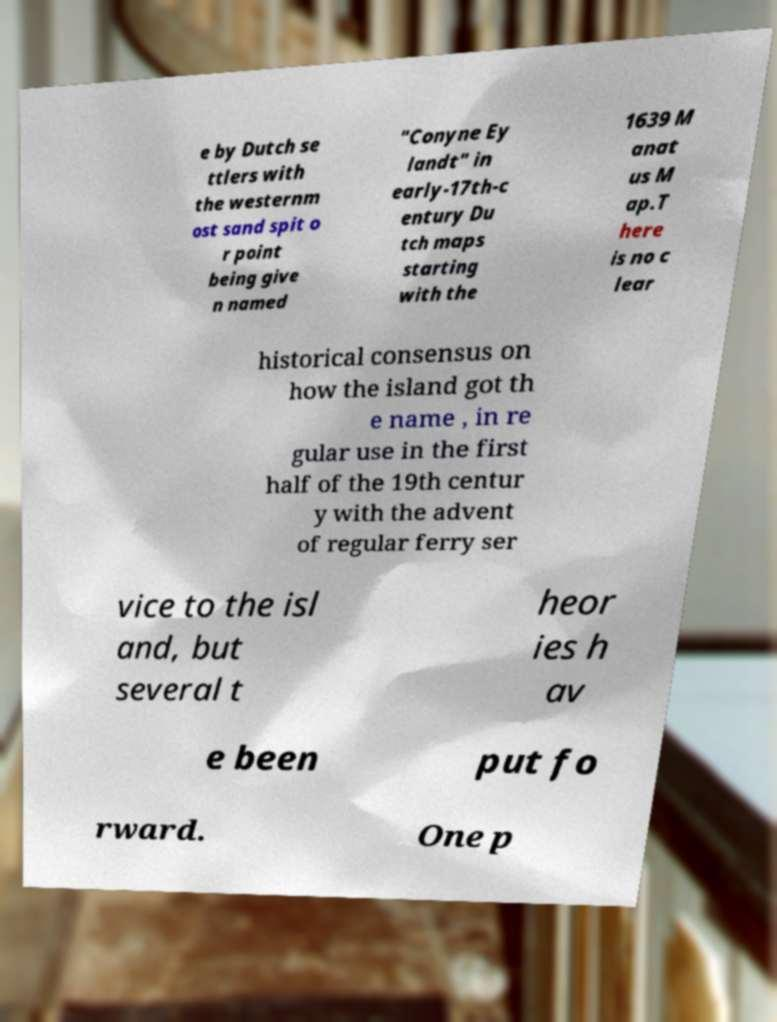There's text embedded in this image that I need extracted. Can you transcribe it verbatim? e by Dutch se ttlers with the westernm ost sand spit o r point being give n named "Conyne Ey landt" in early-17th-c entury Du tch maps starting with the 1639 M anat us M ap.T here is no c lear historical consensus on how the island got th e name , in re gular use in the first half of the 19th centur y with the advent of regular ferry ser vice to the isl and, but several t heor ies h av e been put fo rward. One p 